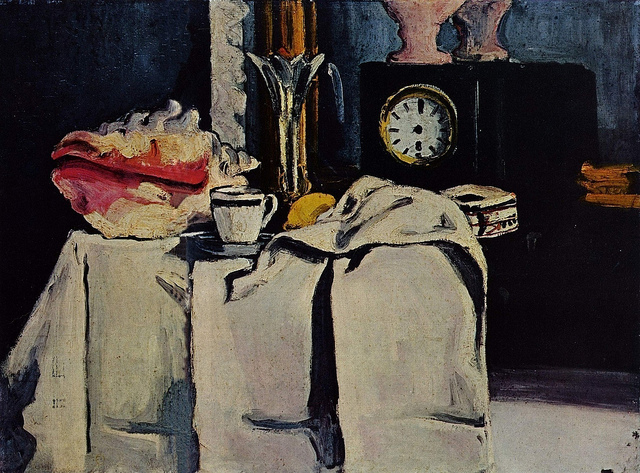<image>What style of painting is this? It's ambiguous to determine the style of the painting. It could be modern, abstract, or even realistic. What style of painting is this? I don't know the style of painting. It can be modern, formal, oil painting, abstract, realism, or classic. 